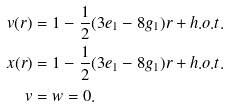Convert formula to latex. <formula><loc_0><loc_0><loc_500><loc_500>v ( r ) & = 1 - \frac { 1 } { 2 } ( 3 e _ { 1 } - 8 g _ { 1 } ) r + h . o . t . \\ x ( r ) & = 1 - \frac { 1 } { 2 } ( 3 e _ { 1 } - 8 g _ { 1 } ) r + h . o . t . \\ v & = w = 0 .</formula> 